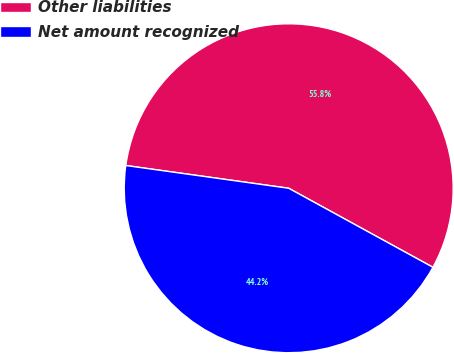Convert chart to OTSL. <chart><loc_0><loc_0><loc_500><loc_500><pie_chart><fcel>Other liabilities<fcel>Net amount recognized<nl><fcel>55.77%<fcel>44.23%<nl></chart> 